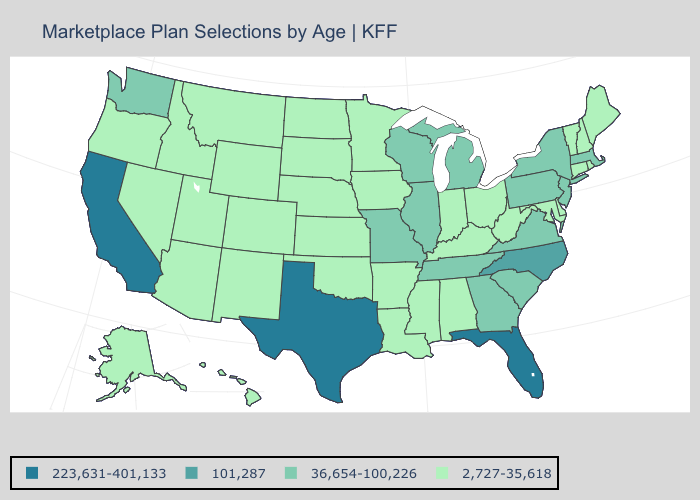Does the first symbol in the legend represent the smallest category?
Give a very brief answer. No. Does the map have missing data?
Answer briefly. No. What is the highest value in the West ?
Write a very short answer. 223,631-401,133. Name the states that have a value in the range 36,654-100,226?
Short answer required. Georgia, Illinois, Massachusetts, Michigan, Missouri, New Jersey, New York, Pennsylvania, South Carolina, Tennessee, Virginia, Washington, Wisconsin. What is the lowest value in the USA?
Write a very short answer. 2,727-35,618. Name the states that have a value in the range 101,287?
Be succinct. North Carolina. Does Louisiana have a lower value than Delaware?
Keep it brief. No. Name the states that have a value in the range 36,654-100,226?
Write a very short answer. Georgia, Illinois, Massachusetts, Michigan, Missouri, New Jersey, New York, Pennsylvania, South Carolina, Tennessee, Virginia, Washington, Wisconsin. Does Kansas have the highest value in the MidWest?
Quick response, please. No. What is the lowest value in the West?
Answer briefly. 2,727-35,618. Does Michigan have a higher value than Illinois?
Concise answer only. No. Which states have the lowest value in the USA?
Short answer required. Alabama, Alaska, Arizona, Arkansas, Colorado, Connecticut, Delaware, Hawaii, Idaho, Indiana, Iowa, Kansas, Kentucky, Louisiana, Maine, Maryland, Minnesota, Mississippi, Montana, Nebraska, Nevada, New Hampshire, New Mexico, North Dakota, Ohio, Oklahoma, Oregon, Rhode Island, South Dakota, Utah, Vermont, West Virginia, Wyoming. Name the states that have a value in the range 36,654-100,226?
Give a very brief answer. Georgia, Illinois, Massachusetts, Michigan, Missouri, New Jersey, New York, Pennsylvania, South Carolina, Tennessee, Virginia, Washington, Wisconsin. Name the states that have a value in the range 2,727-35,618?
Write a very short answer. Alabama, Alaska, Arizona, Arkansas, Colorado, Connecticut, Delaware, Hawaii, Idaho, Indiana, Iowa, Kansas, Kentucky, Louisiana, Maine, Maryland, Minnesota, Mississippi, Montana, Nebraska, Nevada, New Hampshire, New Mexico, North Dakota, Ohio, Oklahoma, Oregon, Rhode Island, South Dakota, Utah, Vermont, West Virginia, Wyoming. 